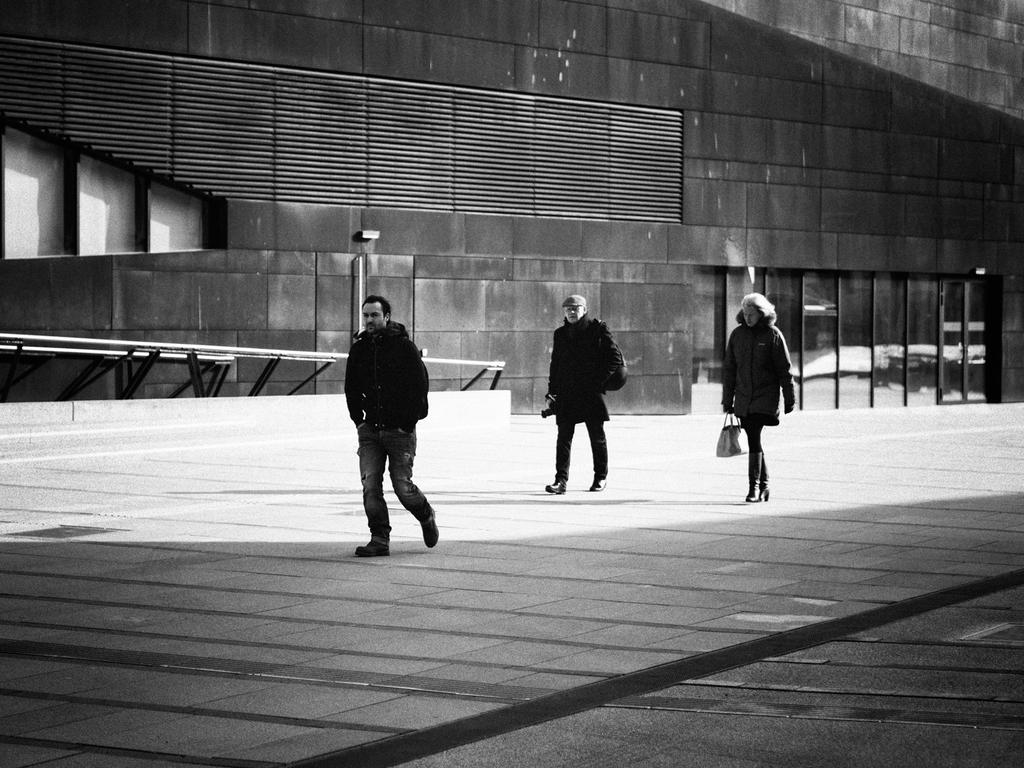What is the color scheme of the image? The image is black and white. How many people are in the image? There are two men and one woman in the image. What is the woman holding in the image? The woman is holding a bag. Where are the people standing in the image? The people are standing on the ground. What can be seen in the background of the image? There is a building visible in the background. What type of silverware is visible in the image? There is no silverware present in the image. Can you tell me how many knees are visible in the image? The image is black and white, and it is not possible to determine the color of the people's clothing or the presence of knees. 